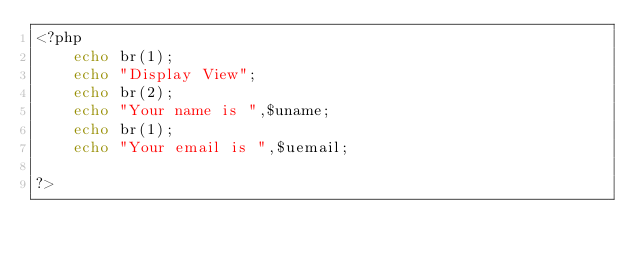Convert code to text. <code><loc_0><loc_0><loc_500><loc_500><_PHP_><?php
    echo br(1);
    echo "Display View";
    echo br(2);
    echo "Your name is ",$uname;
    echo br(1);
    echo "Your email is ",$uemail;

?></code> 